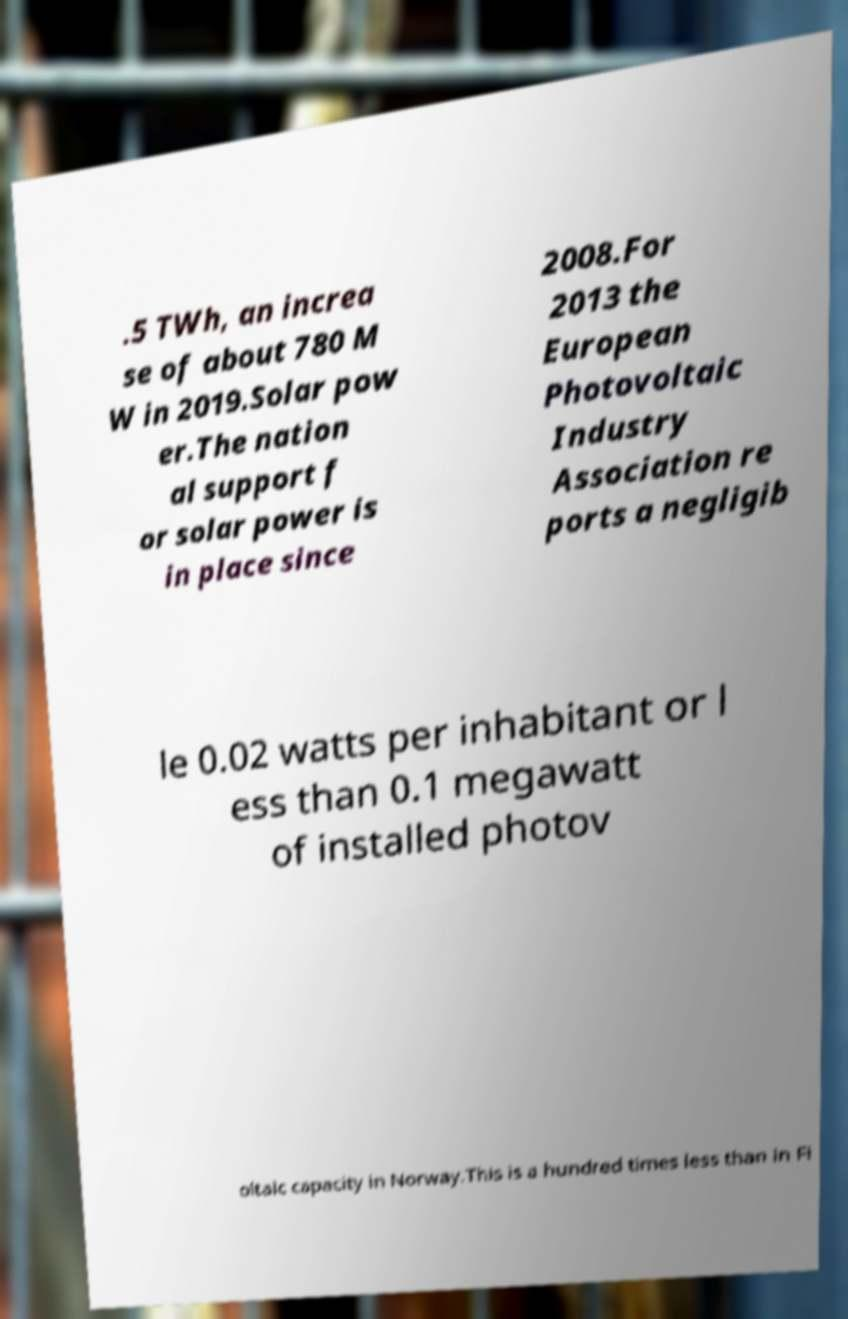Can you read and provide the text displayed in the image?This photo seems to have some interesting text. Can you extract and type it out for me? .5 TWh, an increa se of about 780 M W in 2019.Solar pow er.The nation al support f or solar power is in place since 2008.For 2013 the European Photovoltaic Industry Association re ports a negligib le 0.02 watts per inhabitant or l ess than 0.1 megawatt of installed photov oltaic capacity in Norway.This is a hundred times less than in Fi 